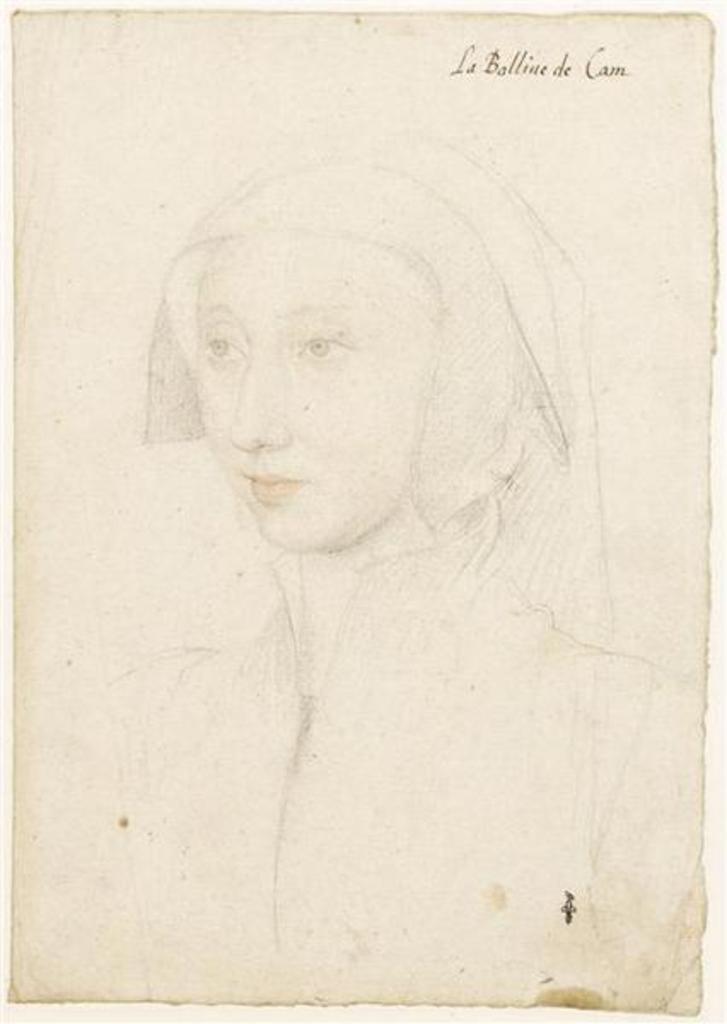Please provide a concise description of this image. This image looks like a painting, in which I can see a woman and text. 